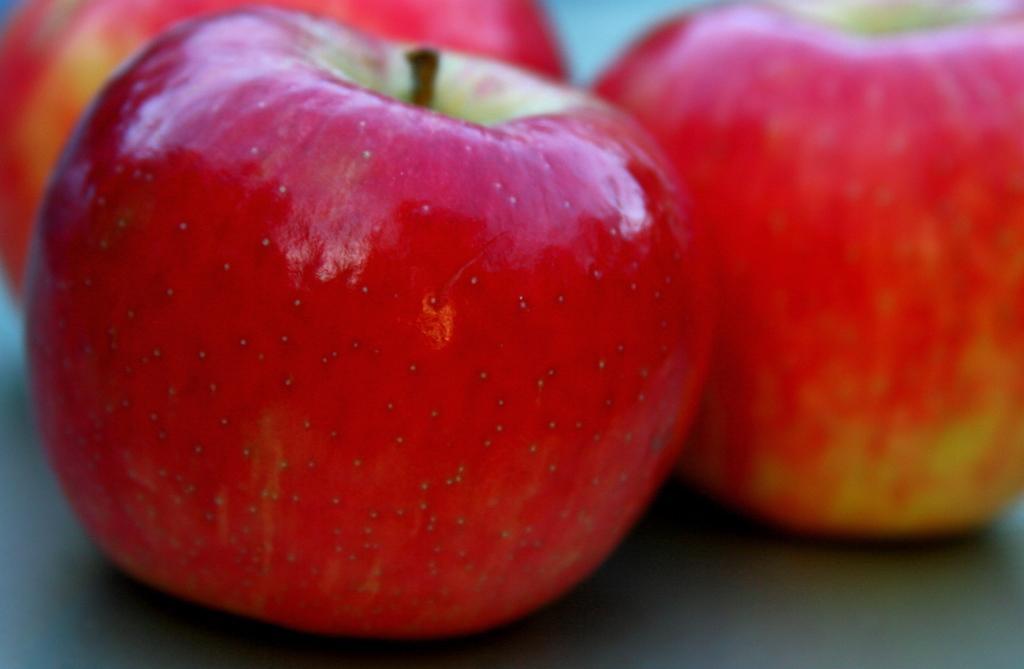Please provide a concise description of this image. There are three apples on a surface. 